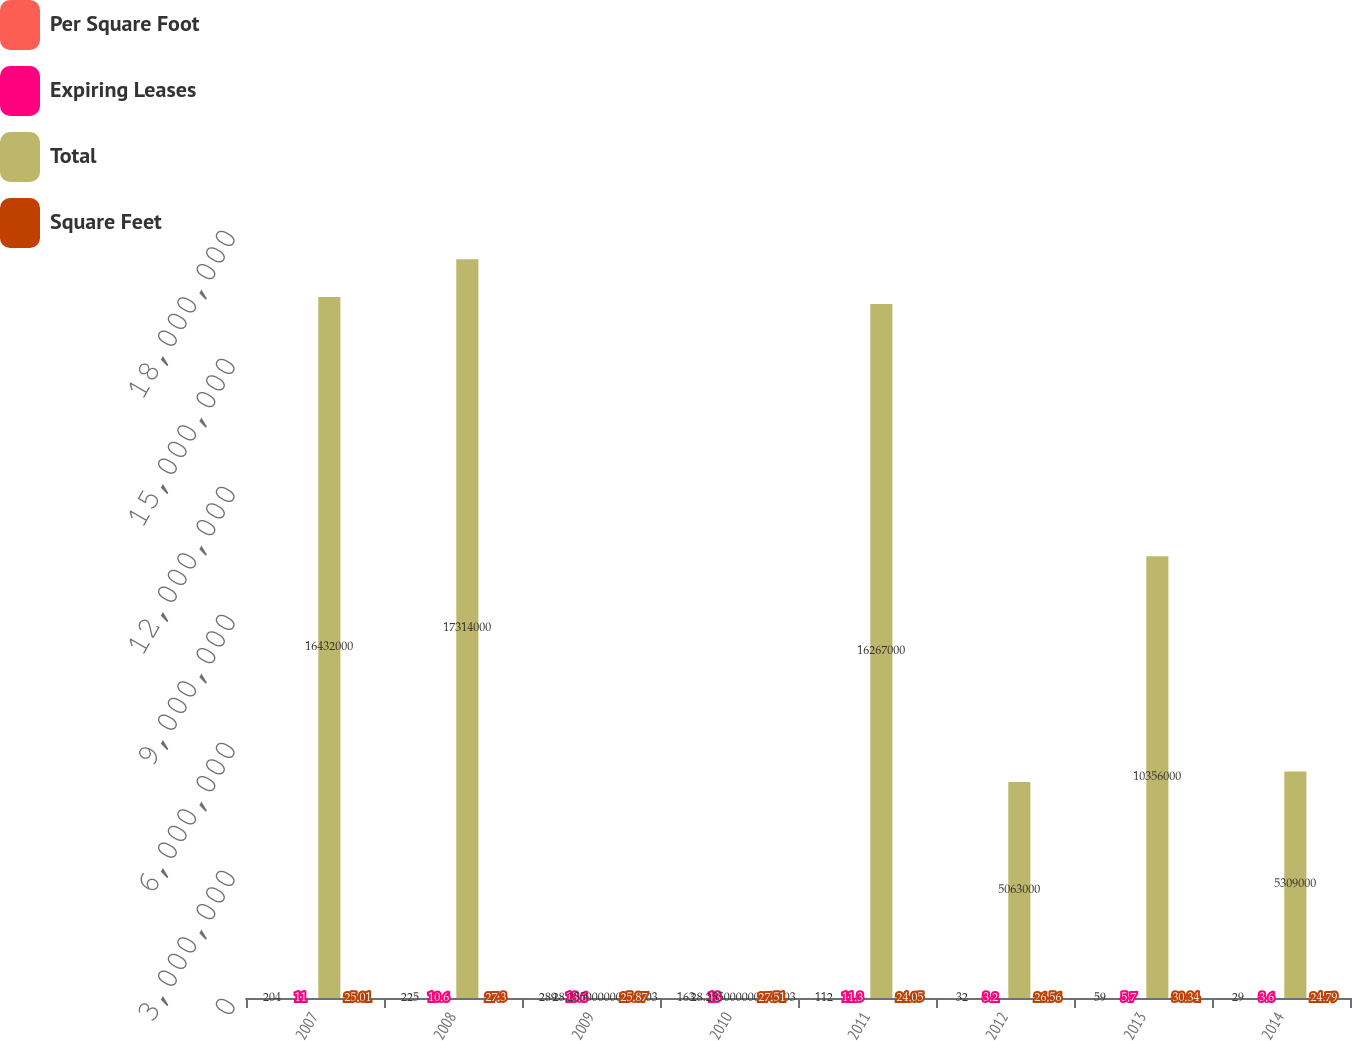Convert chart to OTSL. <chart><loc_0><loc_0><loc_500><loc_500><stacked_bar_chart><ecel><fcel>2007<fcel>2008<fcel>2009<fcel>2010<fcel>2011<fcel>2012<fcel>2013<fcel>2014<nl><fcel>Per Square Foot<fcel>204<fcel>225<fcel>289<fcel>163<fcel>112<fcel>32<fcel>59<fcel>29<nl><fcel>Expiring Leases<fcel>11<fcel>10.6<fcel>13.6<fcel>13<fcel>11.3<fcel>3.2<fcel>5.7<fcel>3.6<nl><fcel>Total<fcel>1.6432e+07<fcel>1.7314e+07<fcel>28.255<fcel>28.255<fcel>1.6267e+07<fcel>5.063e+06<fcel>1.0356e+07<fcel>5.309e+06<nl><fcel>Square Feet<fcel>25.01<fcel>27.3<fcel>25.87<fcel>27.51<fcel>24.05<fcel>26.56<fcel>30.34<fcel>24.79<nl></chart> 